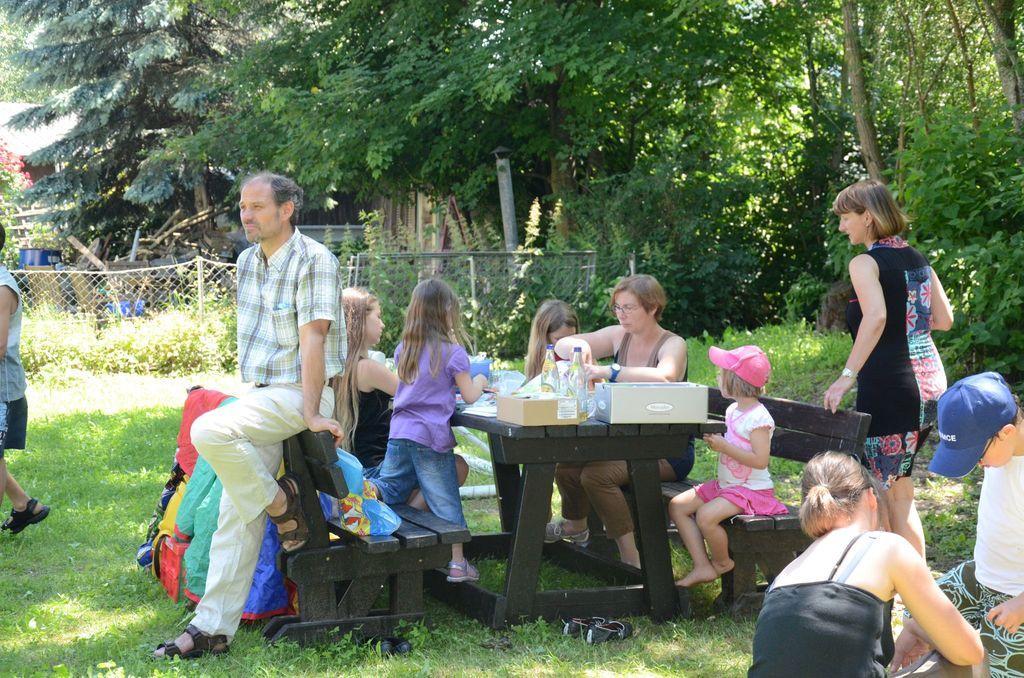How would you summarize this image in a sentence or two? This picture is clicked outside the city. Here, we see woman and children are sitting on bench in front of table. On table, we see cotton boxes, water bottles and plastic covers are placed on it. Behind them, we see a fence and and behind that we see many trees. 